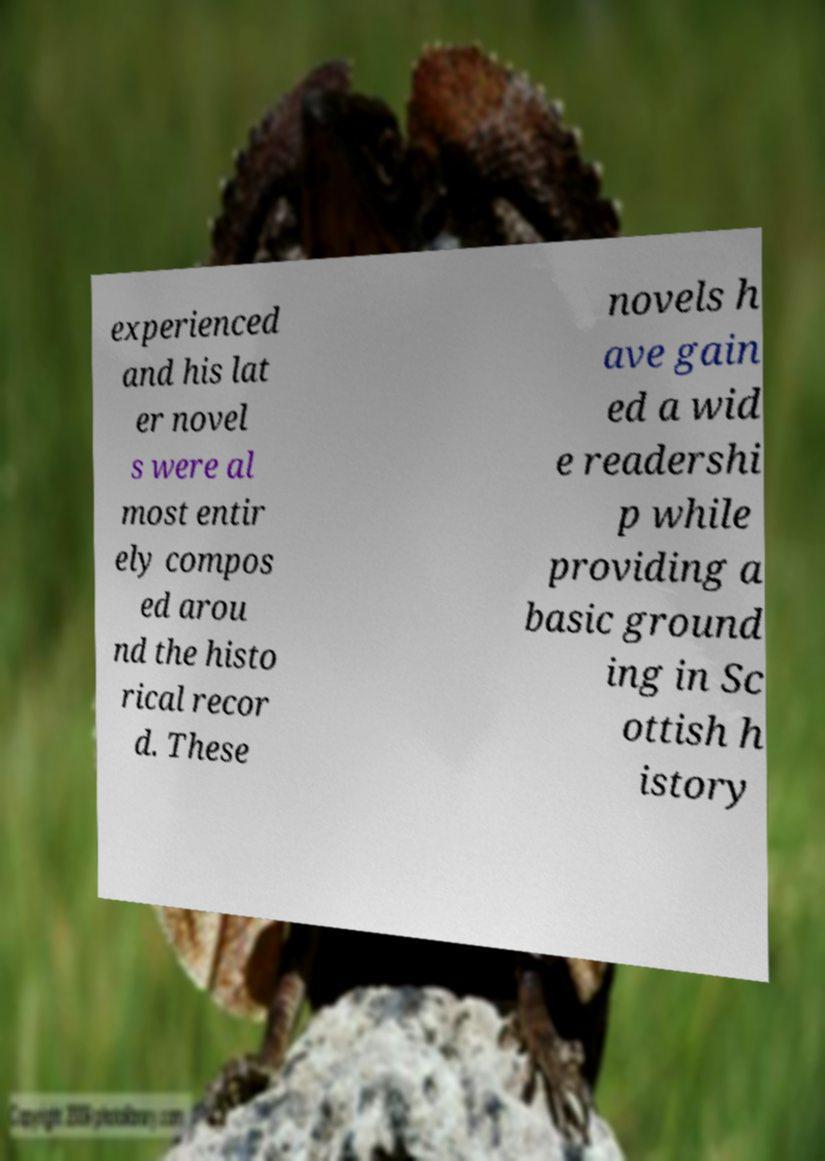Could you extract and type out the text from this image? experienced and his lat er novel s were al most entir ely compos ed arou nd the histo rical recor d. These novels h ave gain ed a wid e readershi p while providing a basic ground ing in Sc ottish h istory 